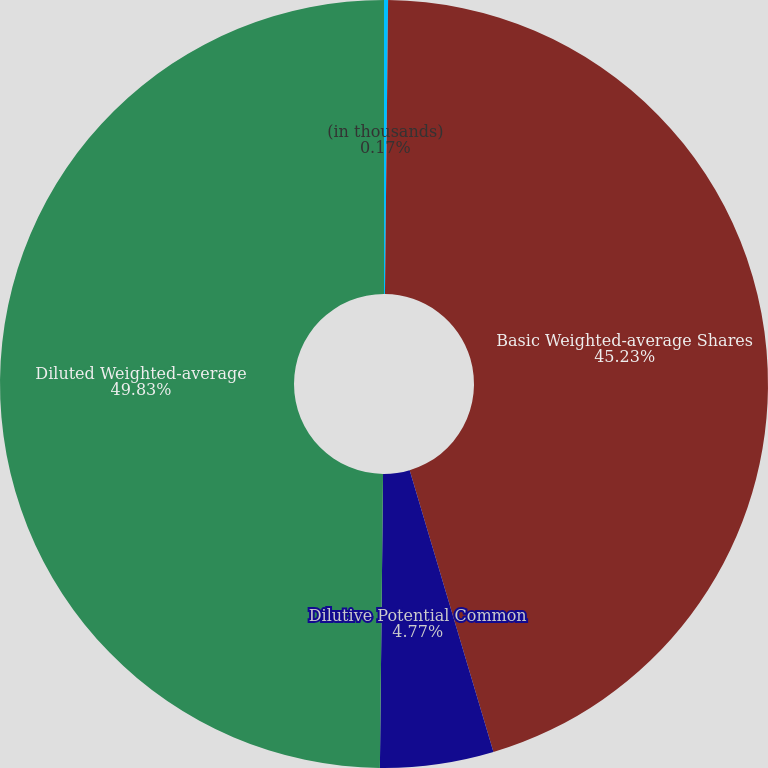Convert chart. <chart><loc_0><loc_0><loc_500><loc_500><pie_chart><fcel>(in thousands)<fcel>Basic Weighted-average Shares<fcel>Dilutive Potential Common<fcel>Diluted Weighted-average<nl><fcel>0.17%<fcel>45.23%<fcel>4.77%<fcel>49.83%<nl></chart> 